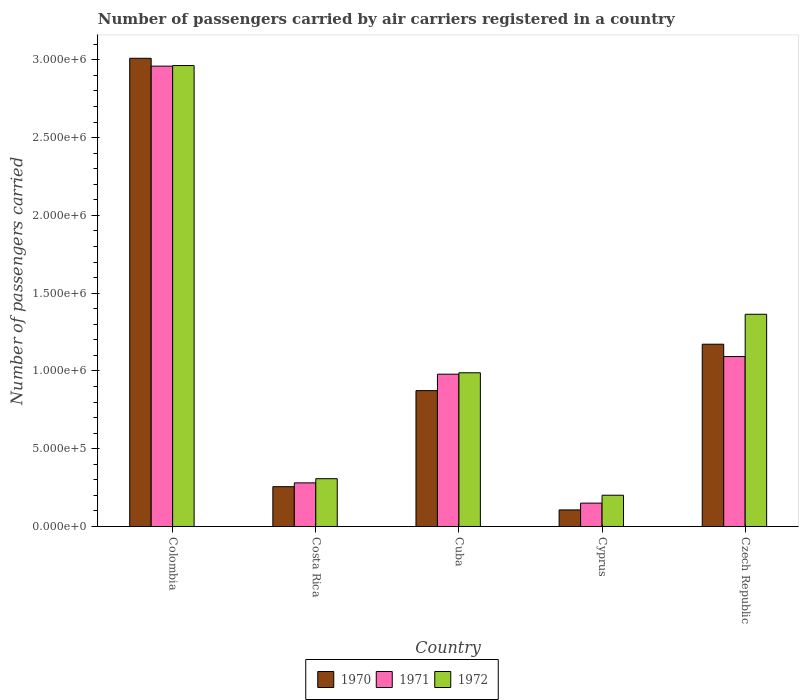How many different coloured bars are there?
Your response must be concise. 3. How many groups of bars are there?
Your answer should be very brief. 5. Are the number of bars per tick equal to the number of legend labels?
Your response must be concise. Yes. How many bars are there on the 4th tick from the left?
Give a very brief answer. 3. How many bars are there on the 1st tick from the right?
Provide a succinct answer. 3. What is the label of the 5th group of bars from the left?
Ensure brevity in your answer.  Czech Republic. In how many cases, is the number of bars for a given country not equal to the number of legend labels?
Your answer should be compact. 0. What is the number of passengers carried by air carriers in 1972 in Cuba?
Make the answer very short. 9.88e+05. Across all countries, what is the maximum number of passengers carried by air carriers in 1970?
Ensure brevity in your answer.  3.01e+06. Across all countries, what is the minimum number of passengers carried by air carriers in 1971?
Give a very brief answer. 1.50e+05. In which country was the number of passengers carried by air carriers in 1971 minimum?
Provide a succinct answer. Cyprus. What is the total number of passengers carried by air carriers in 1970 in the graph?
Offer a terse response. 5.42e+06. What is the difference between the number of passengers carried by air carriers in 1971 in Colombia and that in Czech Republic?
Your answer should be very brief. 1.87e+06. What is the difference between the number of passengers carried by air carriers in 1970 in Colombia and the number of passengers carried by air carriers in 1971 in Cuba?
Your response must be concise. 2.03e+06. What is the average number of passengers carried by air carriers in 1972 per country?
Your response must be concise. 1.16e+06. What is the difference between the number of passengers carried by air carriers of/in 1971 and number of passengers carried by air carriers of/in 1972 in Cuba?
Keep it short and to the point. -9100. What is the ratio of the number of passengers carried by air carriers in 1971 in Colombia to that in Cuba?
Your response must be concise. 3.02. What is the difference between the highest and the second highest number of passengers carried by air carriers in 1971?
Provide a short and direct response. -1.13e+05. What is the difference between the highest and the lowest number of passengers carried by air carriers in 1971?
Offer a terse response. 2.81e+06. In how many countries, is the number of passengers carried by air carriers in 1971 greater than the average number of passengers carried by air carriers in 1971 taken over all countries?
Your response must be concise. 2. Is the sum of the number of passengers carried by air carriers in 1971 in Colombia and Cuba greater than the maximum number of passengers carried by air carriers in 1972 across all countries?
Provide a succinct answer. Yes. Is it the case that in every country, the sum of the number of passengers carried by air carriers in 1972 and number of passengers carried by air carriers in 1970 is greater than the number of passengers carried by air carriers in 1971?
Your answer should be very brief. Yes. How many bars are there?
Keep it short and to the point. 15. Are all the bars in the graph horizontal?
Offer a very short reply. No. How many countries are there in the graph?
Provide a succinct answer. 5. What is the difference between two consecutive major ticks on the Y-axis?
Make the answer very short. 5.00e+05. Are the values on the major ticks of Y-axis written in scientific E-notation?
Your response must be concise. Yes. Where does the legend appear in the graph?
Your response must be concise. Bottom center. What is the title of the graph?
Make the answer very short. Number of passengers carried by air carriers registered in a country. Does "1972" appear as one of the legend labels in the graph?
Provide a short and direct response. Yes. What is the label or title of the Y-axis?
Provide a short and direct response. Number of passengers carried. What is the Number of passengers carried of 1970 in Colombia?
Provide a succinct answer. 3.01e+06. What is the Number of passengers carried in 1971 in Colombia?
Keep it short and to the point. 2.96e+06. What is the Number of passengers carried in 1972 in Colombia?
Offer a very short reply. 2.96e+06. What is the Number of passengers carried of 1970 in Costa Rica?
Offer a very short reply. 2.56e+05. What is the Number of passengers carried in 1971 in Costa Rica?
Make the answer very short. 2.80e+05. What is the Number of passengers carried of 1972 in Costa Rica?
Your answer should be compact. 3.07e+05. What is the Number of passengers carried of 1970 in Cuba?
Keep it short and to the point. 8.74e+05. What is the Number of passengers carried in 1971 in Cuba?
Your answer should be compact. 9.79e+05. What is the Number of passengers carried of 1972 in Cuba?
Ensure brevity in your answer.  9.88e+05. What is the Number of passengers carried in 1970 in Cyprus?
Give a very brief answer. 1.06e+05. What is the Number of passengers carried of 1971 in Cyprus?
Provide a short and direct response. 1.50e+05. What is the Number of passengers carried of 1972 in Cyprus?
Offer a terse response. 2.01e+05. What is the Number of passengers carried of 1970 in Czech Republic?
Ensure brevity in your answer.  1.17e+06. What is the Number of passengers carried of 1971 in Czech Republic?
Give a very brief answer. 1.09e+06. What is the Number of passengers carried of 1972 in Czech Republic?
Offer a terse response. 1.36e+06. Across all countries, what is the maximum Number of passengers carried in 1970?
Give a very brief answer. 3.01e+06. Across all countries, what is the maximum Number of passengers carried in 1971?
Your answer should be very brief. 2.96e+06. Across all countries, what is the maximum Number of passengers carried of 1972?
Provide a short and direct response. 2.96e+06. Across all countries, what is the minimum Number of passengers carried in 1970?
Give a very brief answer. 1.06e+05. Across all countries, what is the minimum Number of passengers carried in 1971?
Offer a very short reply. 1.50e+05. Across all countries, what is the minimum Number of passengers carried of 1972?
Provide a succinct answer. 2.01e+05. What is the total Number of passengers carried of 1970 in the graph?
Keep it short and to the point. 5.42e+06. What is the total Number of passengers carried of 1971 in the graph?
Your answer should be very brief. 5.46e+06. What is the total Number of passengers carried in 1972 in the graph?
Your answer should be compact. 5.82e+06. What is the difference between the Number of passengers carried in 1970 in Colombia and that in Costa Rica?
Your answer should be very brief. 2.75e+06. What is the difference between the Number of passengers carried of 1971 in Colombia and that in Costa Rica?
Give a very brief answer. 2.68e+06. What is the difference between the Number of passengers carried in 1972 in Colombia and that in Costa Rica?
Give a very brief answer. 2.66e+06. What is the difference between the Number of passengers carried in 1970 in Colombia and that in Cuba?
Provide a succinct answer. 2.14e+06. What is the difference between the Number of passengers carried in 1971 in Colombia and that in Cuba?
Your response must be concise. 1.98e+06. What is the difference between the Number of passengers carried in 1972 in Colombia and that in Cuba?
Give a very brief answer. 1.98e+06. What is the difference between the Number of passengers carried in 1970 in Colombia and that in Cyprus?
Provide a short and direct response. 2.90e+06. What is the difference between the Number of passengers carried of 1971 in Colombia and that in Cyprus?
Offer a very short reply. 2.81e+06. What is the difference between the Number of passengers carried of 1972 in Colombia and that in Cyprus?
Your answer should be compact. 2.76e+06. What is the difference between the Number of passengers carried in 1970 in Colombia and that in Czech Republic?
Offer a very short reply. 1.84e+06. What is the difference between the Number of passengers carried in 1971 in Colombia and that in Czech Republic?
Offer a very short reply. 1.87e+06. What is the difference between the Number of passengers carried of 1972 in Colombia and that in Czech Republic?
Make the answer very short. 1.60e+06. What is the difference between the Number of passengers carried in 1970 in Costa Rica and that in Cuba?
Your answer should be very brief. -6.18e+05. What is the difference between the Number of passengers carried in 1971 in Costa Rica and that in Cuba?
Your answer should be compact. -6.99e+05. What is the difference between the Number of passengers carried in 1972 in Costa Rica and that in Cuba?
Give a very brief answer. -6.81e+05. What is the difference between the Number of passengers carried of 1970 in Costa Rica and that in Cyprus?
Keep it short and to the point. 1.49e+05. What is the difference between the Number of passengers carried in 1971 in Costa Rica and that in Cyprus?
Give a very brief answer. 1.30e+05. What is the difference between the Number of passengers carried in 1972 in Costa Rica and that in Cyprus?
Provide a succinct answer. 1.06e+05. What is the difference between the Number of passengers carried in 1970 in Costa Rica and that in Czech Republic?
Ensure brevity in your answer.  -9.16e+05. What is the difference between the Number of passengers carried of 1971 in Costa Rica and that in Czech Republic?
Keep it short and to the point. -8.12e+05. What is the difference between the Number of passengers carried of 1972 in Costa Rica and that in Czech Republic?
Your response must be concise. -1.06e+06. What is the difference between the Number of passengers carried in 1970 in Cuba and that in Cyprus?
Provide a short and direct response. 7.67e+05. What is the difference between the Number of passengers carried of 1971 in Cuba and that in Cyprus?
Your answer should be compact. 8.29e+05. What is the difference between the Number of passengers carried in 1972 in Cuba and that in Cyprus?
Offer a terse response. 7.87e+05. What is the difference between the Number of passengers carried in 1970 in Cuba and that in Czech Republic?
Make the answer very short. -2.98e+05. What is the difference between the Number of passengers carried of 1971 in Cuba and that in Czech Republic?
Your answer should be compact. -1.13e+05. What is the difference between the Number of passengers carried in 1972 in Cuba and that in Czech Republic?
Offer a terse response. -3.76e+05. What is the difference between the Number of passengers carried of 1970 in Cyprus and that in Czech Republic?
Ensure brevity in your answer.  -1.07e+06. What is the difference between the Number of passengers carried in 1971 in Cyprus and that in Czech Republic?
Make the answer very short. -9.42e+05. What is the difference between the Number of passengers carried of 1972 in Cyprus and that in Czech Republic?
Your response must be concise. -1.16e+06. What is the difference between the Number of passengers carried in 1970 in Colombia and the Number of passengers carried in 1971 in Costa Rica?
Give a very brief answer. 2.73e+06. What is the difference between the Number of passengers carried in 1970 in Colombia and the Number of passengers carried in 1972 in Costa Rica?
Your answer should be compact. 2.70e+06. What is the difference between the Number of passengers carried in 1971 in Colombia and the Number of passengers carried in 1972 in Costa Rica?
Your answer should be compact. 2.65e+06. What is the difference between the Number of passengers carried of 1970 in Colombia and the Number of passengers carried of 1971 in Cuba?
Your answer should be very brief. 2.03e+06. What is the difference between the Number of passengers carried of 1970 in Colombia and the Number of passengers carried of 1972 in Cuba?
Offer a terse response. 2.02e+06. What is the difference between the Number of passengers carried in 1971 in Colombia and the Number of passengers carried in 1972 in Cuba?
Your answer should be very brief. 1.97e+06. What is the difference between the Number of passengers carried in 1970 in Colombia and the Number of passengers carried in 1971 in Cyprus?
Offer a terse response. 2.86e+06. What is the difference between the Number of passengers carried in 1970 in Colombia and the Number of passengers carried in 1972 in Cyprus?
Keep it short and to the point. 2.81e+06. What is the difference between the Number of passengers carried of 1971 in Colombia and the Number of passengers carried of 1972 in Cyprus?
Ensure brevity in your answer.  2.76e+06. What is the difference between the Number of passengers carried of 1970 in Colombia and the Number of passengers carried of 1971 in Czech Republic?
Ensure brevity in your answer.  1.92e+06. What is the difference between the Number of passengers carried of 1970 in Colombia and the Number of passengers carried of 1972 in Czech Republic?
Provide a short and direct response. 1.65e+06. What is the difference between the Number of passengers carried in 1971 in Colombia and the Number of passengers carried in 1972 in Czech Republic?
Your answer should be compact. 1.60e+06. What is the difference between the Number of passengers carried of 1970 in Costa Rica and the Number of passengers carried of 1971 in Cuba?
Make the answer very short. -7.23e+05. What is the difference between the Number of passengers carried of 1970 in Costa Rica and the Number of passengers carried of 1972 in Cuba?
Make the answer very short. -7.32e+05. What is the difference between the Number of passengers carried in 1971 in Costa Rica and the Number of passengers carried in 1972 in Cuba?
Your answer should be very brief. -7.08e+05. What is the difference between the Number of passengers carried of 1970 in Costa Rica and the Number of passengers carried of 1971 in Cyprus?
Offer a terse response. 1.06e+05. What is the difference between the Number of passengers carried in 1970 in Costa Rica and the Number of passengers carried in 1972 in Cyprus?
Keep it short and to the point. 5.49e+04. What is the difference between the Number of passengers carried in 1971 in Costa Rica and the Number of passengers carried in 1972 in Cyprus?
Your response must be concise. 7.94e+04. What is the difference between the Number of passengers carried of 1970 in Costa Rica and the Number of passengers carried of 1971 in Czech Republic?
Offer a very short reply. -8.37e+05. What is the difference between the Number of passengers carried of 1970 in Costa Rica and the Number of passengers carried of 1972 in Czech Republic?
Your response must be concise. -1.11e+06. What is the difference between the Number of passengers carried in 1971 in Costa Rica and the Number of passengers carried in 1972 in Czech Republic?
Your response must be concise. -1.08e+06. What is the difference between the Number of passengers carried in 1970 in Cuba and the Number of passengers carried in 1971 in Cyprus?
Your response must be concise. 7.23e+05. What is the difference between the Number of passengers carried of 1970 in Cuba and the Number of passengers carried of 1972 in Cyprus?
Make the answer very short. 6.72e+05. What is the difference between the Number of passengers carried of 1971 in Cuba and the Number of passengers carried of 1972 in Cyprus?
Your answer should be compact. 7.78e+05. What is the difference between the Number of passengers carried of 1970 in Cuba and the Number of passengers carried of 1971 in Czech Republic?
Make the answer very short. -2.19e+05. What is the difference between the Number of passengers carried of 1970 in Cuba and the Number of passengers carried of 1972 in Czech Republic?
Make the answer very short. -4.91e+05. What is the difference between the Number of passengers carried in 1971 in Cuba and the Number of passengers carried in 1972 in Czech Republic?
Your answer should be very brief. -3.85e+05. What is the difference between the Number of passengers carried of 1970 in Cyprus and the Number of passengers carried of 1971 in Czech Republic?
Give a very brief answer. -9.86e+05. What is the difference between the Number of passengers carried in 1970 in Cyprus and the Number of passengers carried in 1972 in Czech Republic?
Keep it short and to the point. -1.26e+06. What is the difference between the Number of passengers carried of 1971 in Cyprus and the Number of passengers carried of 1972 in Czech Republic?
Offer a terse response. -1.21e+06. What is the average Number of passengers carried in 1970 per country?
Ensure brevity in your answer.  1.08e+06. What is the average Number of passengers carried in 1971 per country?
Your answer should be compact. 1.09e+06. What is the average Number of passengers carried in 1972 per country?
Your answer should be very brief. 1.16e+06. What is the difference between the Number of passengers carried of 1970 and Number of passengers carried of 1971 in Colombia?
Your answer should be very brief. 5.05e+04. What is the difference between the Number of passengers carried in 1970 and Number of passengers carried in 1972 in Colombia?
Offer a terse response. 4.66e+04. What is the difference between the Number of passengers carried in 1971 and Number of passengers carried in 1972 in Colombia?
Ensure brevity in your answer.  -3900. What is the difference between the Number of passengers carried in 1970 and Number of passengers carried in 1971 in Costa Rica?
Ensure brevity in your answer.  -2.45e+04. What is the difference between the Number of passengers carried of 1970 and Number of passengers carried of 1972 in Costa Rica?
Your response must be concise. -5.14e+04. What is the difference between the Number of passengers carried of 1971 and Number of passengers carried of 1972 in Costa Rica?
Your response must be concise. -2.69e+04. What is the difference between the Number of passengers carried in 1970 and Number of passengers carried in 1971 in Cuba?
Offer a very short reply. -1.06e+05. What is the difference between the Number of passengers carried in 1970 and Number of passengers carried in 1972 in Cuba?
Your answer should be very brief. -1.15e+05. What is the difference between the Number of passengers carried in 1971 and Number of passengers carried in 1972 in Cuba?
Your answer should be compact. -9100. What is the difference between the Number of passengers carried in 1970 and Number of passengers carried in 1971 in Cyprus?
Keep it short and to the point. -4.37e+04. What is the difference between the Number of passengers carried of 1970 and Number of passengers carried of 1972 in Cyprus?
Your answer should be compact. -9.45e+04. What is the difference between the Number of passengers carried in 1971 and Number of passengers carried in 1972 in Cyprus?
Provide a succinct answer. -5.08e+04. What is the difference between the Number of passengers carried of 1970 and Number of passengers carried of 1971 in Czech Republic?
Offer a very short reply. 7.94e+04. What is the difference between the Number of passengers carried of 1970 and Number of passengers carried of 1972 in Czech Republic?
Your response must be concise. -1.92e+05. What is the difference between the Number of passengers carried of 1971 and Number of passengers carried of 1972 in Czech Republic?
Your response must be concise. -2.72e+05. What is the ratio of the Number of passengers carried in 1970 in Colombia to that in Costa Rica?
Your response must be concise. 11.76. What is the ratio of the Number of passengers carried in 1971 in Colombia to that in Costa Rica?
Provide a short and direct response. 10.56. What is the ratio of the Number of passengers carried in 1972 in Colombia to that in Costa Rica?
Provide a short and direct response. 9.64. What is the ratio of the Number of passengers carried of 1970 in Colombia to that in Cuba?
Offer a very short reply. 3.45. What is the ratio of the Number of passengers carried of 1971 in Colombia to that in Cuba?
Offer a terse response. 3.02. What is the ratio of the Number of passengers carried of 1972 in Colombia to that in Cuba?
Give a very brief answer. 3. What is the ratio of the Number of passengers carried of 1970 in Colombia to that in Cyprus?
Your response must be concise. 28.26. What is the ratio of the Number of passengers carried in 1971 in Colombia to that in Cyprus?
Give a very brief answer. 19.71. What is the ratio of the Number of passengers carried of 1972 in Colombia to that in Cyprus?
Your response must be concise. 14.74. What is the ratio of the Number of passengers carried of 1970 in Colombia to that in Czech Republic?
Your answer should be compact. 2.57. What is the ratio of the Number of passengers carried in 1971 in Colombia to that in Czech Republic?
Ensure brevity in your answer.  2.71. What is the ratio of the Number of passengers carried of 1972 in Colombia to that in Czech Republic?
Your response must be concise. 2.17. What is the ratio of the Number of passengers carried in 1970 in Costa Rica to that in Cuba?
Offer a very short reply. 0.29. What is the ratio of the Number of passengers carried of 1971 in Costa Rica to that in Cuba?
Give a very brief answer. 0.29. What is the ratio of the Number of passengers carried of 1972 in Costa Rica to that in Cuba?
Your answer should be compact. 0.31. What is the ratio of the Number of passengers carried of 1970 in Costa Rica to that in Cyprus?
Your answer should be compact. 2.4. What is the ratio of the Number of passengers carried of 1971 in Costa Rica to that in Cyprus?
Your answer should be very brief. 1.87. What is the ratio of the Number of passengers carried of 1972 in Costa Rica to that in Cyprus?
Keep it short and to the point. 1.53. What is the ratio of the Number of passengers carried of 1970 in Costa Rica to that in Czech Republic?
Your answer should be very brief. 0.22. What is the ratio of the Number of passengers carried in 1971 in Costa Rica to that in Czech Republic?
Offer a very short reply. 0.26. What is the ratio of the Number of passengers carried in 1972 in Costa Rica to that in Czech Republic?
Give a very brief answer. 0.23. What is the ratio of the Number of passengers carried in 1970 in Cuba to that in Cyprus?
Keep it short and to the point. 8.2. What is the ratio of the Number of passengers carried of 1971 in Cuba to that in Cyprus?
Provide a succinct answer. 6.52. What is the ratio of the Number of passengers carried of 1972 in Cuba to that in Cyprus?
Give a very brief answer. 4.92. What is the ratio of the Number of passengers carried of 1970 in Cuba to that in Czech Republic?
Offer a very short reply. 0.75. What is the ratio of the Number of passengers carried in 1971 in Cuba to that in Czech Republic?
Your response must be concise. 0.9. What is the ratio of the Number of passengers carried of 1972 in Cuba to that in Czech Republic?
Ensure brevity in your answer.  0.72. What is the ratio of the Number of passengers carried in 1970 in Cyprus to that in Czech Republic?
Your response must be concise. 0.09. What is the ratio of the Number of passengers carried of 1971 in Cyprus to that in Czech Republic?
Your answer should be compact. 0.14. What is the ratio of the Number of passengers carried of 1972 in Cyprus to that in Czech Republic?
Make the answer very short. 0.15. What is the difference between the highest and the second highest Number of passengers carried in 1970?
Give a very brief answer. 1.84e+06. What is the difference between the highest and the second highest Number of passengers carried in 1971?
Provide a short and direct response. 1.87e+06. What is the difference between the highest and the second highest Number of passengers carried of 1972?
Provide a short and direct response. 1.60e+06. What is the difference between the highest and the lowest Number of passengers carried of 1970?
Provide a short and direct response. 2.90e+06. What is the difference between the highest and the lowest Number of passengers carried in 1971?
Ensure brevity in your answer.  2.81e+06. What is the difference between the highest and the lowest Number of passengers carried in 1972?
Your answer should be compact. 2.76e+06. 